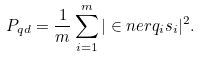Convert formula to latex. <formula><loc_0><loc_0><loc_500><loc_500>P _ { q d } = \frac { 1 } { m } \sum _ { i = 1 } ^ { m } | \in n e r { q _ { i } } { s _ { i } } | ^ { 2 } .</formula> 